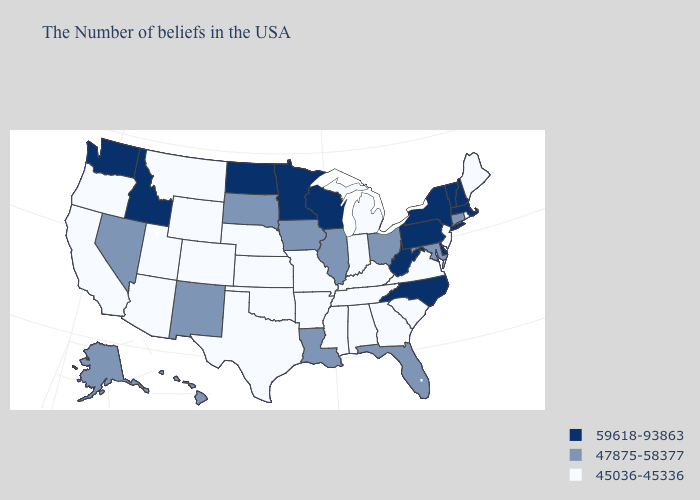Name the states that have a value in the range 45036-45336?
Write a very short answer. Maine, Rhode Island, New Jersey, Virginia, South Carolina, Georgia, Michigan, Kentucky, Indiana, Alabama, Tennessee, Mississippi, Missouri, Arkansas, Kansas, Nebraska, Oklahoma, Texas, Wyoming, Colorado, Utah, Montana, Arizona, California, Oregon. Among the states that border Georgia , which have the lowest value?
Be succinct. South Carolina, Alabama, Tennessee. What is the highest value in the South ?
Write a very short answer. 59618-93863. Which states have the lowest value in the South?
Concise answer only. Virginia, South Carolina, Georgia, Kentucky, Alabama, Tennessee, Mississippi, Arkansas, Oklahoma, Texas. Does Maryland have the same value as New York?
Give a very brief answer. No. What is the value of North Carolina?
Be succinct. 59618-93863. What is the value of Kansas?
Keep it brief. 45036-45336. What is the value of Mississippi?
Short answer required. 45036-45336. Name the states that have a value in the range 45036-45336?
Keep it brief. Maine, Rhode Island, New Jersey, Virginia, South Carolina, Georgia, Michigan, Kentucky, Indiana, Alabama, Tennessee, Mississippi, Missouri, Arkansas, Kansas, Nebraska, Oklahoma, Texas, Wyoming, Colorado, Utah, Montana, Arizona, California, Oregon. Name the states that have a value in the range 47875-58377?
Be succinct. Connecticut, Maryland, Ohio, Florida, Illinois, Louisiana, Iowa, South Dakota, New Mexico, Nevada, Alaska, Hawaii. Among the states that border North Dakota , does South Dakota have the lowest value?
Short answer required. No. How many symbols are there in the legend?
Write a very short answer. 3. What is the value of Rhode Island?
Keep it brief. 45036-45336. Which states have the lowest value in the USA?
Short answer required. Maine, Rhode Island, New Jersey, Virginia, South Carolina, Georgia, Michigan, Kentucky, Indiana, Alabama, Tennessee, Mississippi, Missouri, Arkansas, Kansas, Nebraska, Oklahoma, Texas, Wyoming, Colorado, Utah, Montana, Arizona, California, Oregon. What is the value of Iowa?
Concise answer only. 47875-58377. 